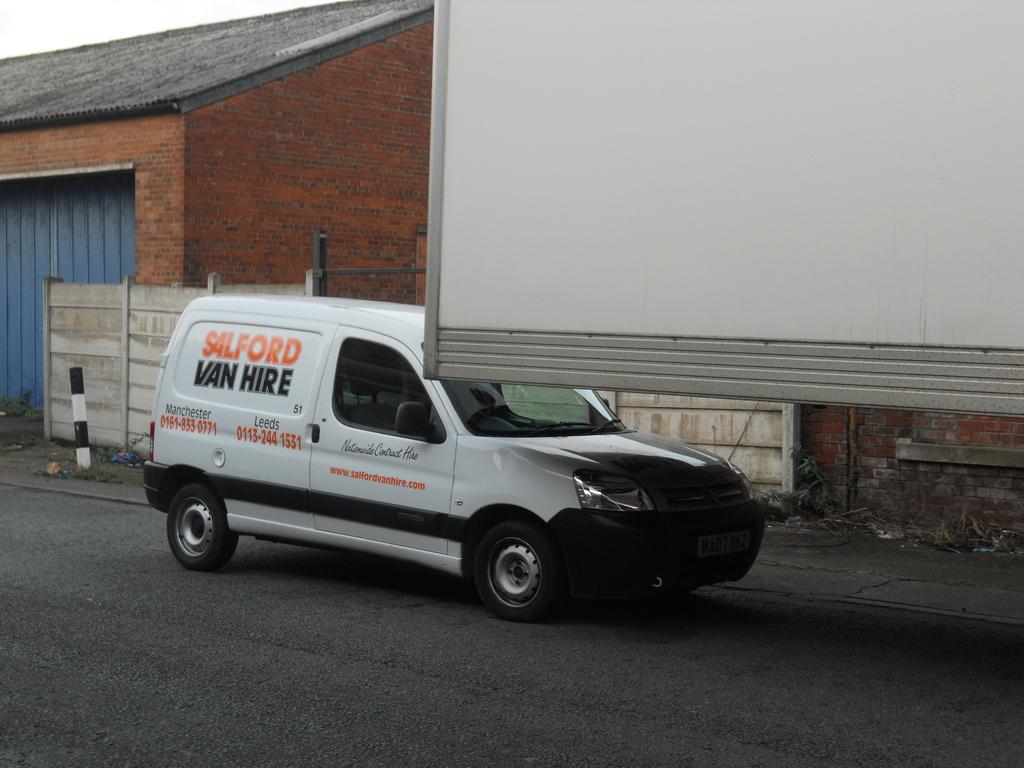<image>
Render a clear and concise summary of the photo. A white van behind a trailer reads Salford Van Hire. 